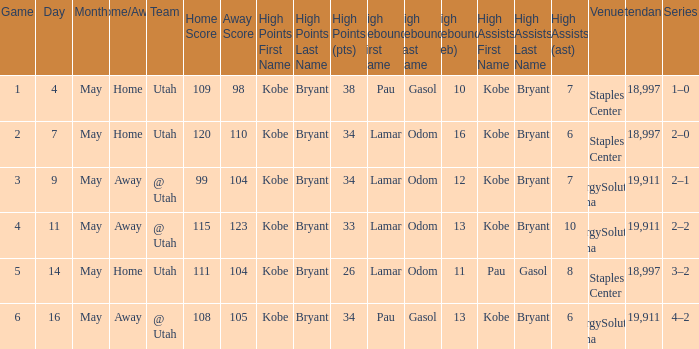What is the Series with a High rebounds with gasol (10)? 1–0. 